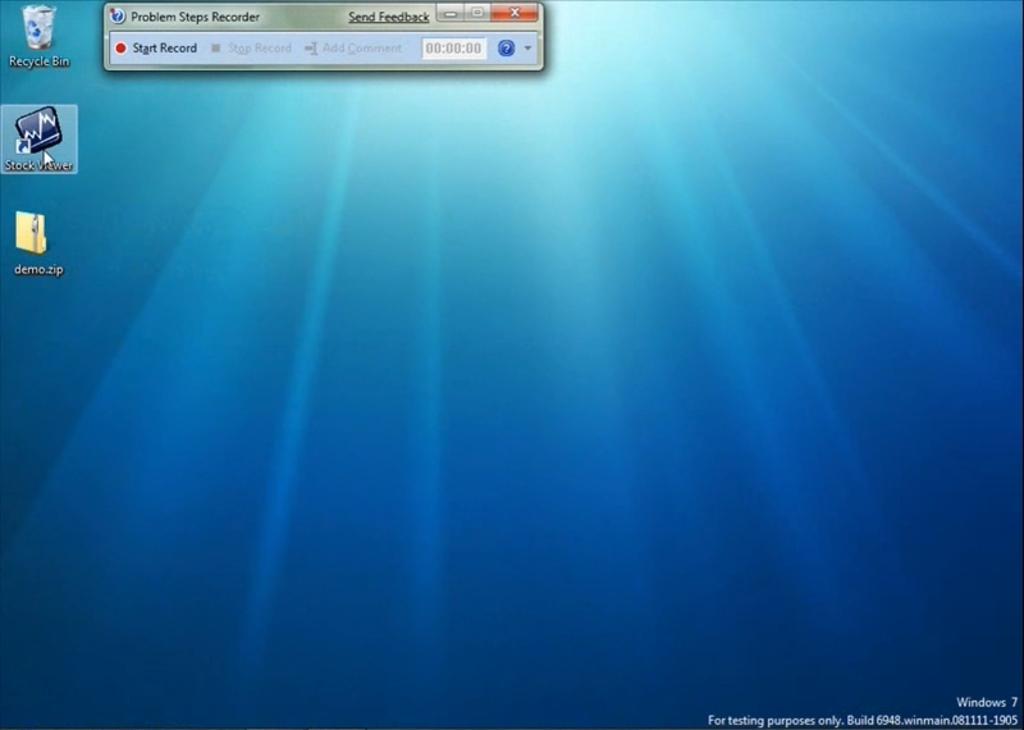Window screen or not?
Your answer should be compact. Yes. 